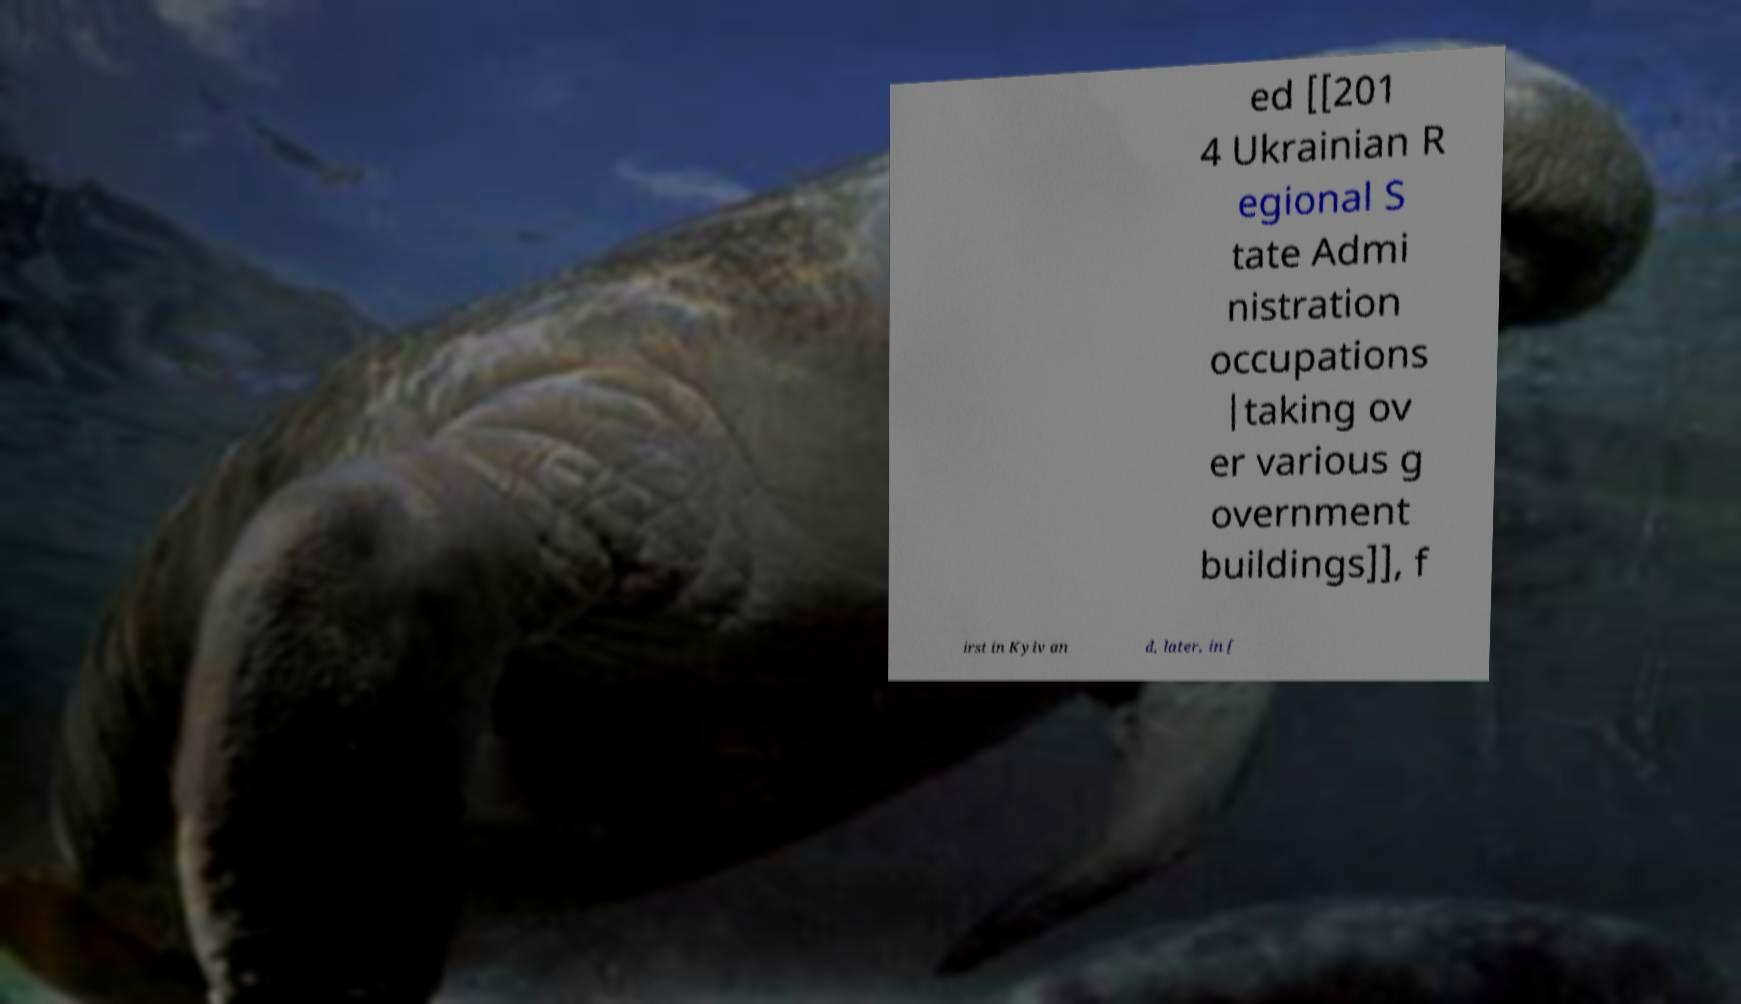For documentation purposes, I need the text within this image transcribed. Could you provide that? ed [[201 4 Ukrainian R egional S tate Admi nistration occupations |taking ov er various g overnment buildings]], f irst in Kyiv an d, later, in [ 